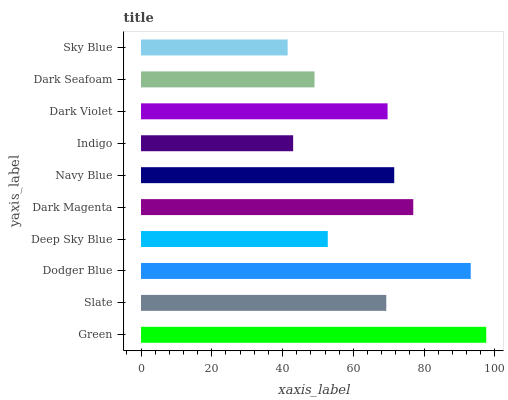Is Sky Blue the minimum?
Answer yes or no. Yes. Is Green the maximum?
Answer yes or no. Yes. Is Slate the minimum?
Answer yes or no. No. Is Slate the maximum?
Answer yes or no. No. Is Green greater than Slate?
Answer yes or no. Yes. Is Slate less than Green?
Answer yes or no. Yes. Is Slate greater than Green?
Answer yes or no. No. Is Green less than Slate?
Answer yes or no. No. Is Dark Violet the high median?
Answer yes or no. Yes. Is Slate the low median?
Answer yes or no. Yes. Is Dark Seafoam the high median?
Answer yes or no. No. Is Dark Seafoam the low median?
Answer yes or no. No. 